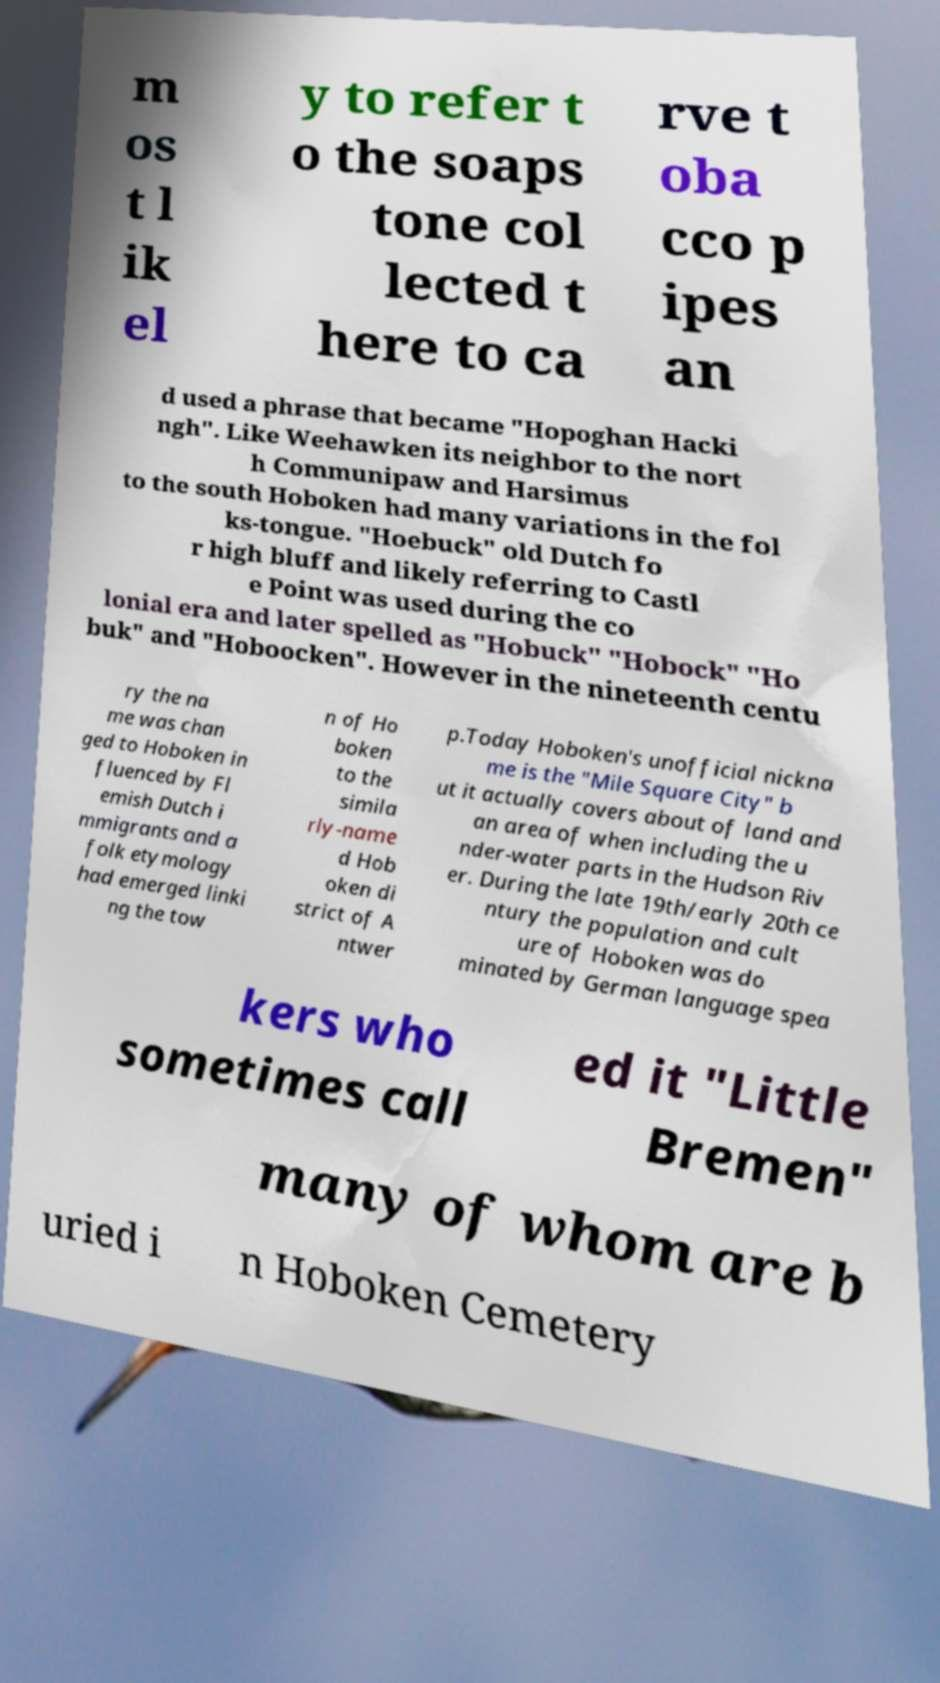Please identify and transcribe the text found in this image. m os t l ik el y to refer t o the soaps tone col lected t here to ca rve t oba cco p ipes an d used a phrase that became "Hopoghan Hacki ngh". Like Weehawken its neighbor to the nort h Communipaw and Harsimus to the south Hoboken had many variations in the fol ks-tongue. "Hoebuck" old Dutch fo r high bluff and likely referring to Castl e Point was used during the co lonial era and later spelled as "Hobuck" "Hobock" "Ho buk" and "Hoboocken". However in the nineteenth centu ry the na me was chan ged to Hoboken in fluenced by Fl emish Dutch i mmigrants and a folk etymology had emerged linki ng the tow n of Ho boken to the simila rly-name d Hob oken di strict of A ntwer p.Today Hoboken's unofficial nickna me is the "Mile Square City" b ut it actually covers about of land and an area of when including the u nder-water parts in the Hudson Riv er. During the late 19th/early 20th ce ntury the population and cult ure of Hoboken was do minated by German language spea kers who sometimes call ed it "Little Bremen" many of whom are b uried i n Hoboken Cemetery 